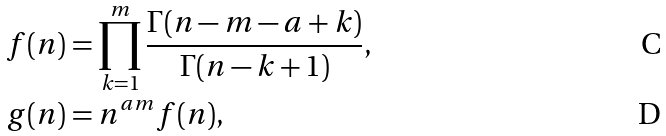<formula> <loc_0><loc_0><loc_500><loc_500>f ( n ) & = \prod _ { k = 1 } ^ { m } \frac { \Gamma ( n - m - a + k ) } { \Gamma ( n - k + 1 ) } , \\ g ( n ) & = n ^ { a m } f ( n ) ,</formula> 